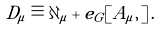Convert formula to latex. <formula><loc_0><loc_0><loc_500><loc_500>D _ { \mu } \equiv \partial _ { \mu } + e _ { G } [ A _ { \mu } , \, ] \, .</formula> 